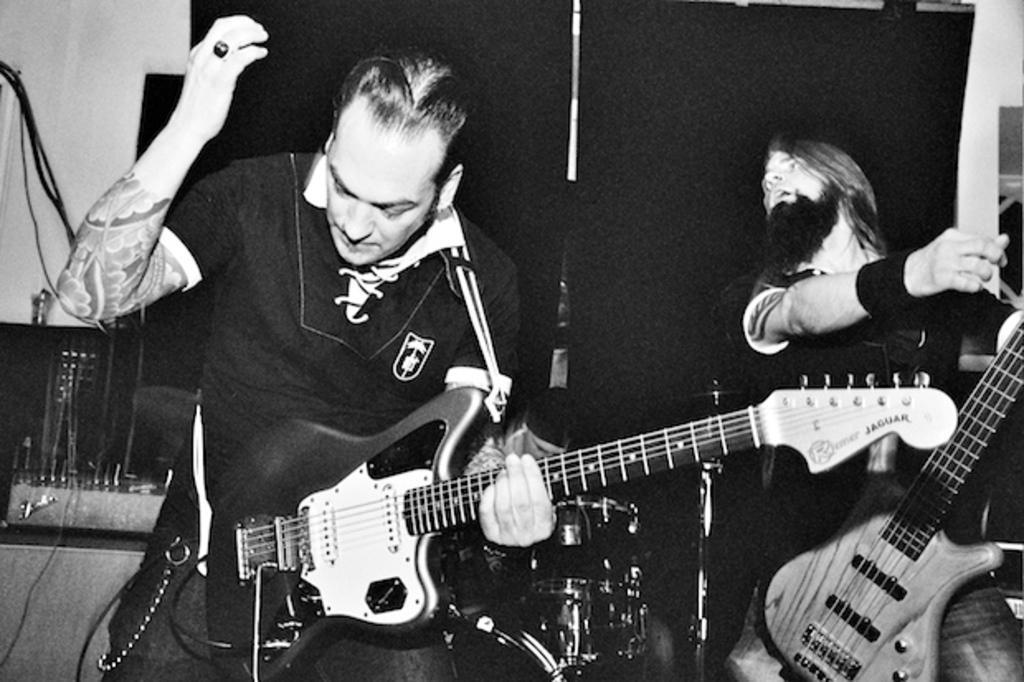In one or two sentences, can you explain what this image depicts? In this black and white image, we can see two persons holding guitars with their hands. There are musical drums at the bottom of the image. There is an another person in the middle of the image. There is a musical equipment in the bottom left of the image. 